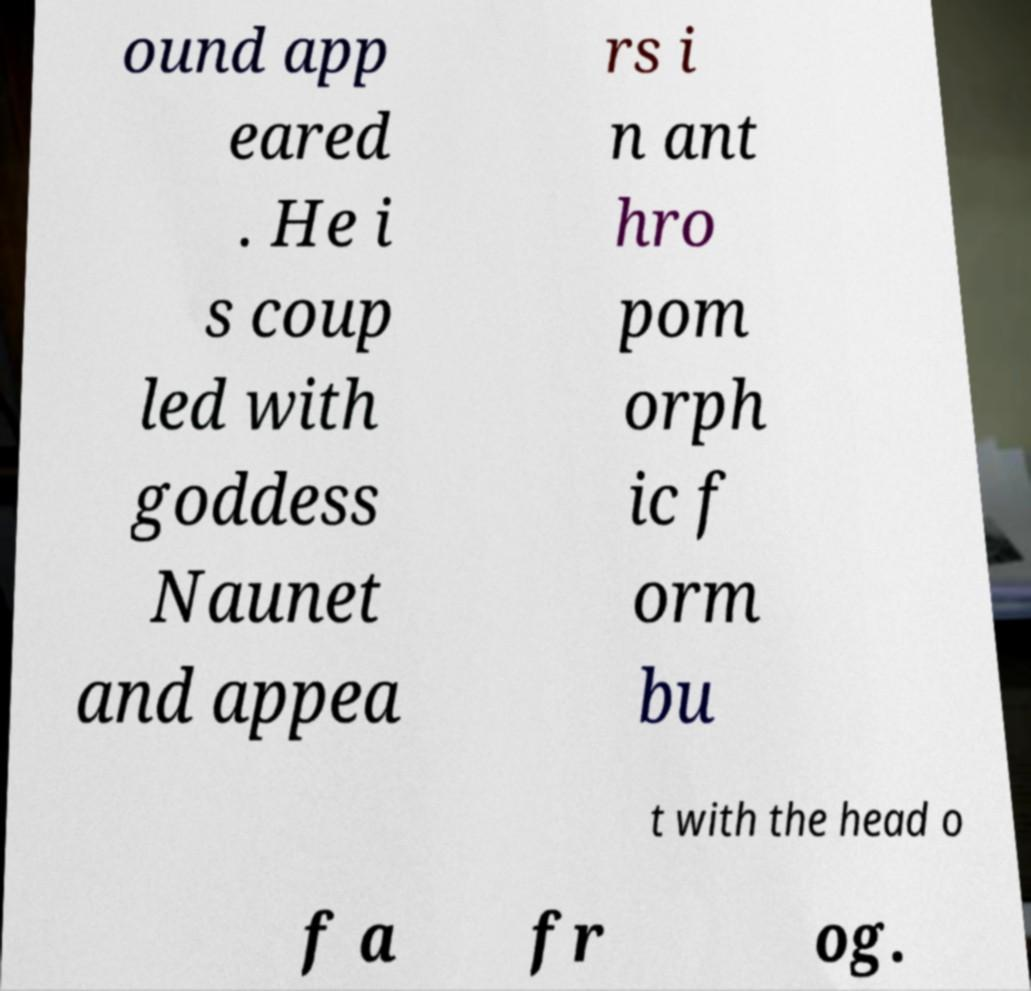There's text embedded in this image that I need extracted. Can you transcribe it verbatim? ound app eared . He i s coup led with goddess Naunet and appea rs i n ant hro pom orph ic f orm bu t with the head o f a fr og. 